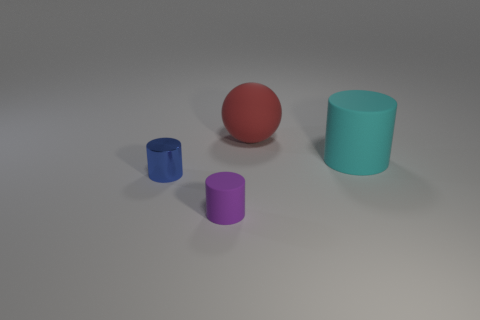How many blocks are there? The image does not contain any block-shaped objects. Instead, it showcases a total of four objects: one red sphere, one blue cylinder, one purple cylinder, and one small blue cup or cylinder. 